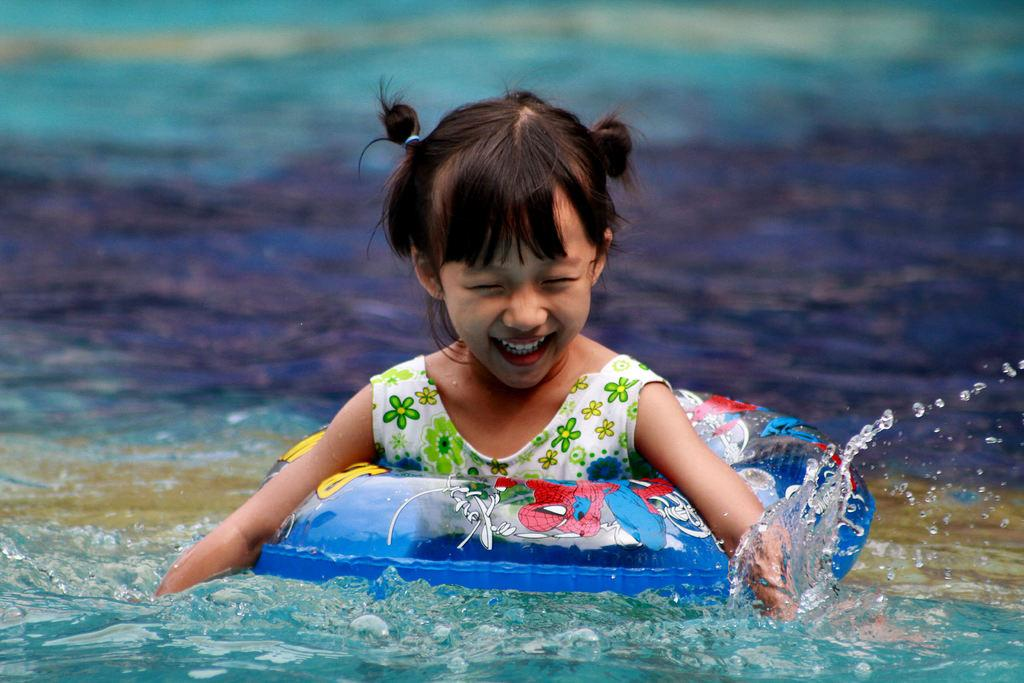Who is the main subject in the image? There is a girl in the image. What is the girl wearing? The girl is wearing clothes. What is the girl's facial expression in the image? The girl is smiling. What can be seen in the image besides the girl? There is a water tube and water visible in the image. How would you describe the background of the image? The background of the image is blurred. What type of toy is the girl playing with in the image? There is no toy present in the image; the girl is interacting with a water tube. Who is the girl's friend in the image? There is no friend visible in the image; the girl is alone. 